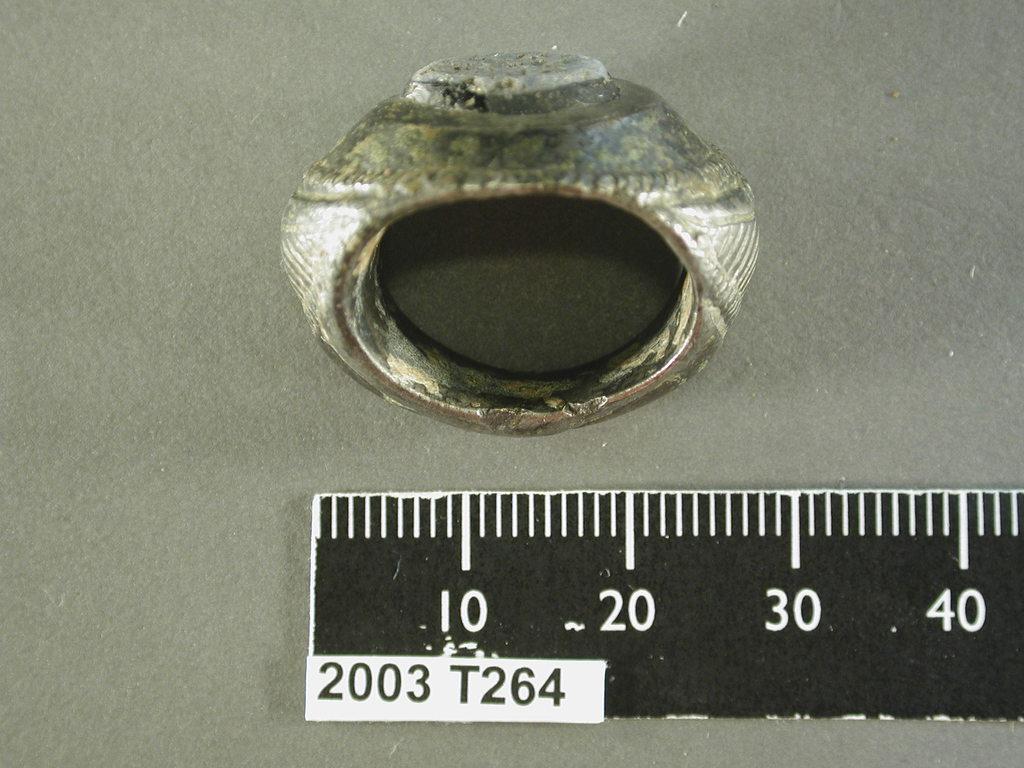What number size is the ring?
Give a very brief answer. 30. What is the largest measurement shown on the ruler?
Offer a very short reply. 40. 